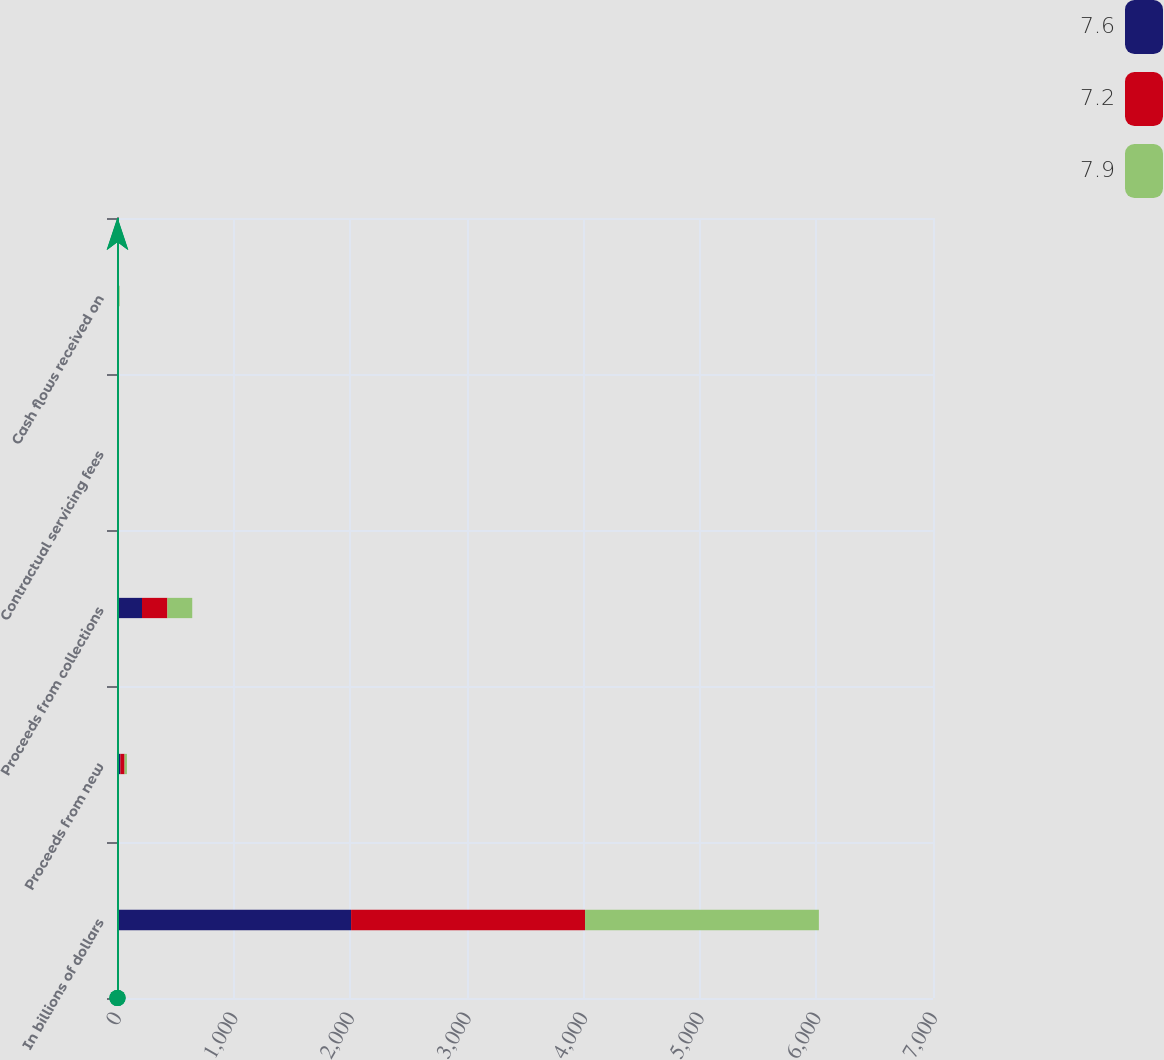<chart> <loc_0><loc_0><loc_500><loc_500><stacked_bar_chart><ecel><fcel>In billions of dollars<fcel>Proceeds from new<fcel>Proceeds from collections<fcel>Contractual servicing fees<fcel>Cash flows received on<nl><fcel>7.6<fcel>2008<fcel>28.7<fcel>214.3<fcel>2<fcel>7.2<nl><fcel>7.2<fcel>2007<fcel>36.2<fcel>218<fcel>2.1<fcel>7.6<nl><fcel>7.9<fcel>2006<fcel>20.2<fcel>213.1<fcel>2.1<fcel>7.9<nl></chart> 